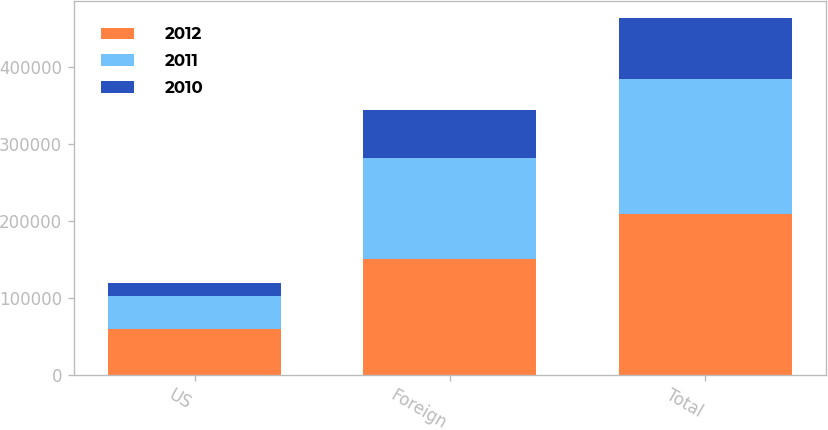<chart> <loc_0><loc_0><loc_500><loc_500><stacked_bar_chart><ecel><fcel>US<fcel>Foreign<fcel>Total<nl><fcel>2012<fcel>58964<fcel>150251<fcel>209215<nl><fcel>2011<fcel>42637<fcel>131947<fcel>174584<nl><fcel>2010<fcel>17879<fcel>61373<fcel>79252<nl></chart> 